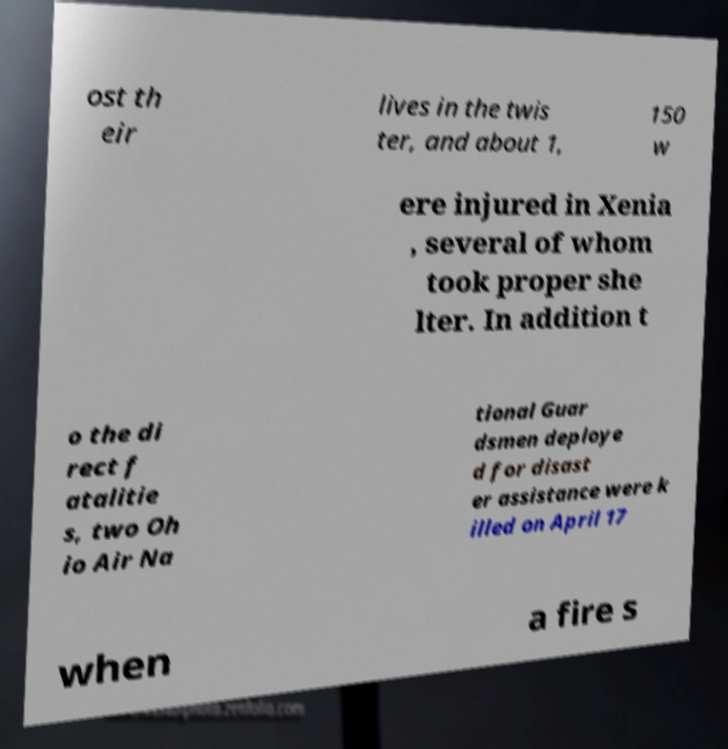Could you assist in decoding the text presented in this image and type it out clearly? ost th eir lives in the twis ter, and about 1, 150 w ere injured in Xenia , several of whom took proper she lter. In addition t o the di rect f atalitie s, two Oh io Air Na tional Guar dsmen deploye d for disast er assistance were k illed on April 17 when a fire s 